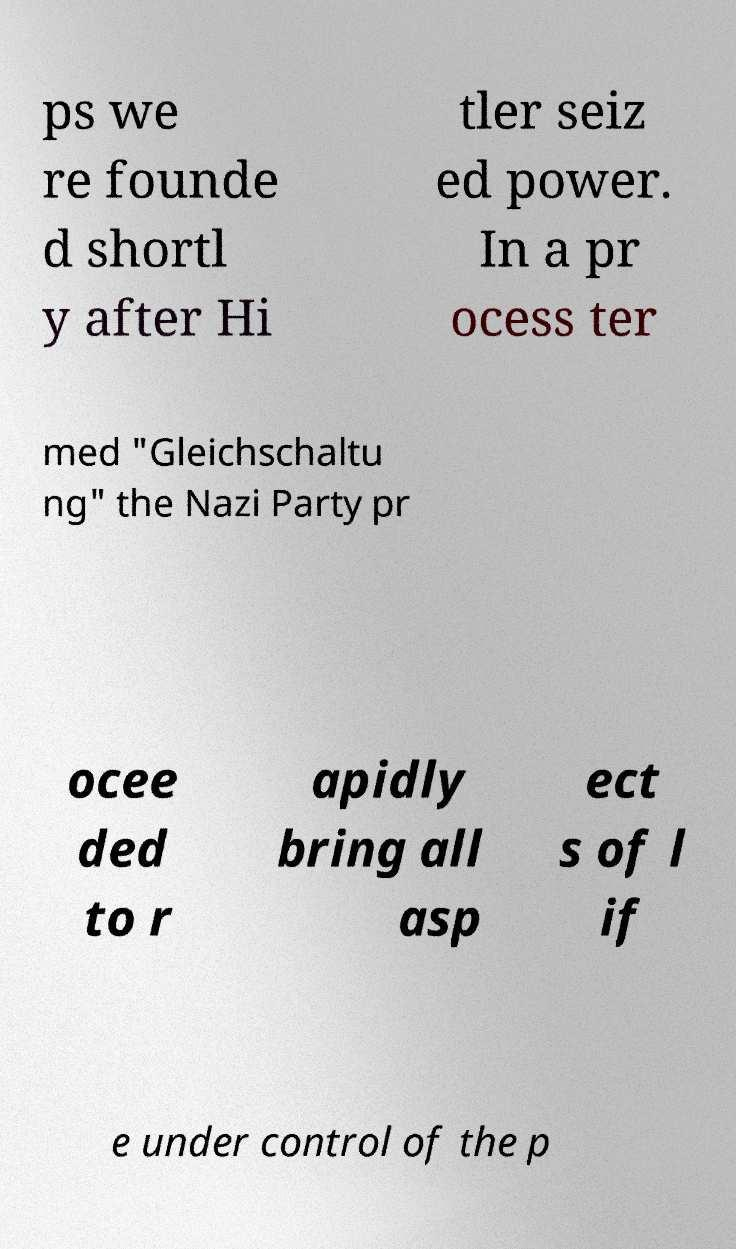Can you read and provide the text displayed in the image?This photo seems to have some interesting text. Can you extract and type it out for me? ps we re founde d shortl y after Hi tler seiz ed power. In a pr ocess ter med "Gleichschaltu ng" the Nazi Party pr ocee ded to r apidly bring all asp ect s of l if e under control of the p 